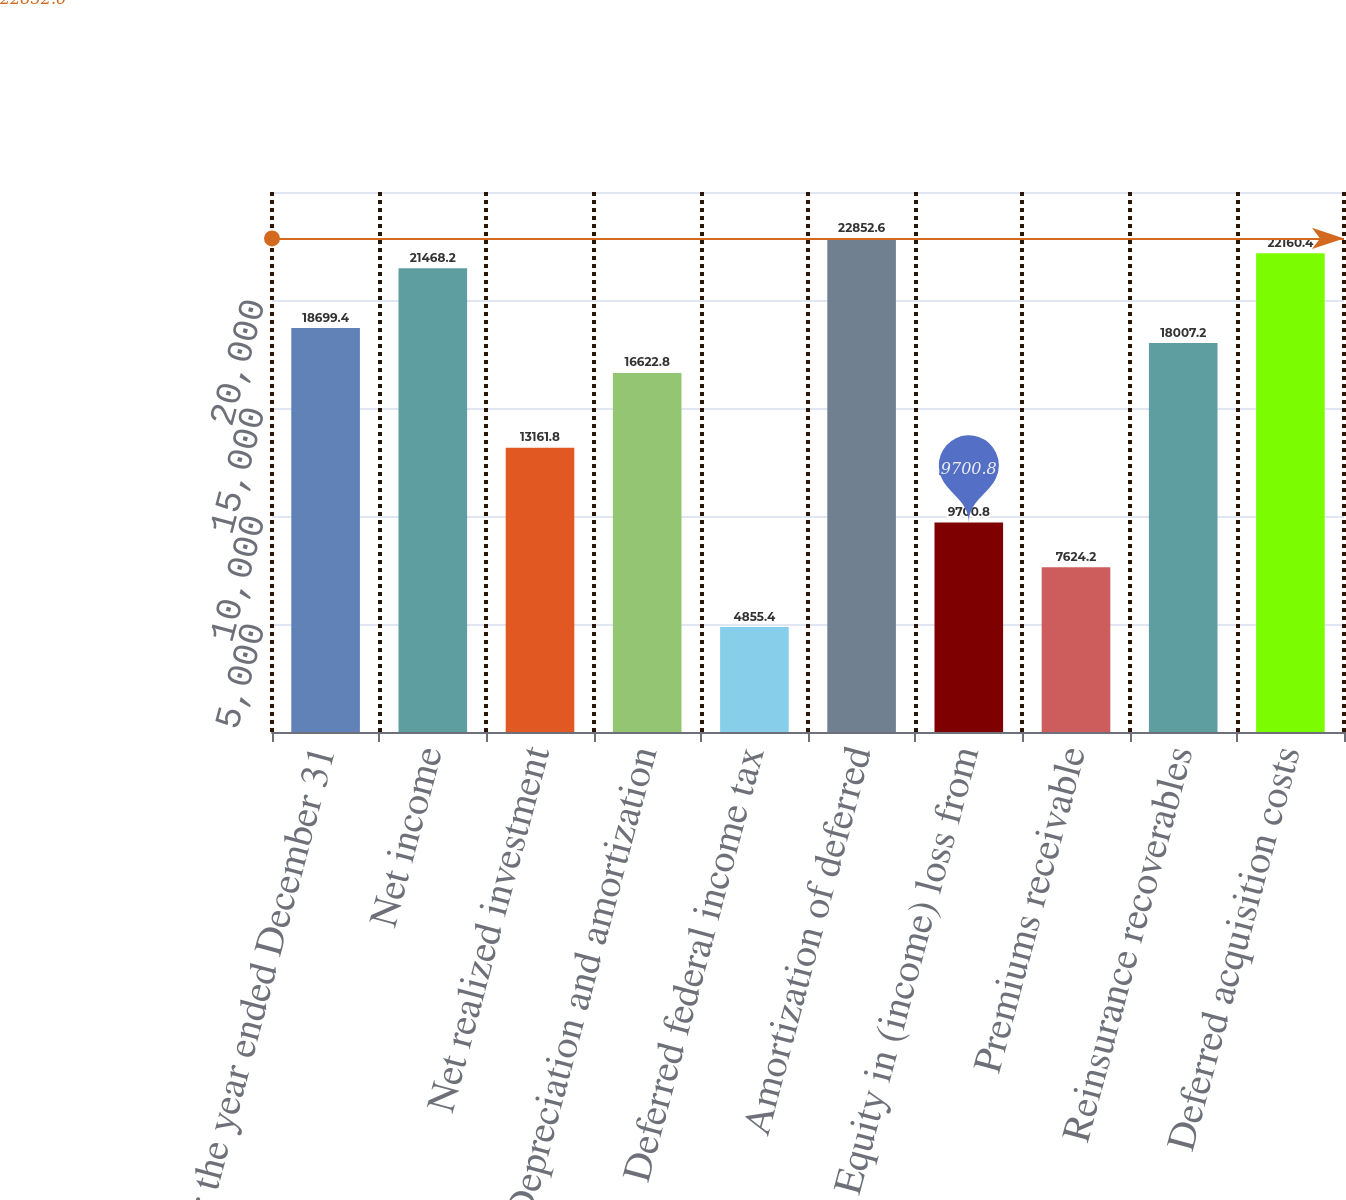<chart> <loc_0><loc_0><loc_500><loc_500><bar_chart><fcel>For the year ended December 31<fcel>Net income<fcel>Net realized investment<fcel>Depreciation and amortization<fcel>Deferred federal income tax<fcel>Amortization of deferred<fcel>Equity in (income) loss from<fcel>Premiums receivable<fcel>Reinsurance recoverables<fcel>Deferred acquisition costs<nl><fcel>18699.4<fcel>21468.2<fcel>13161.8<fcel>16622.8<fcel>4855.4<fcel>22852.6<fcel>9700.8<fcel>7624.2<fcel>18007.2<fcel>22160.4<nl></chart> 